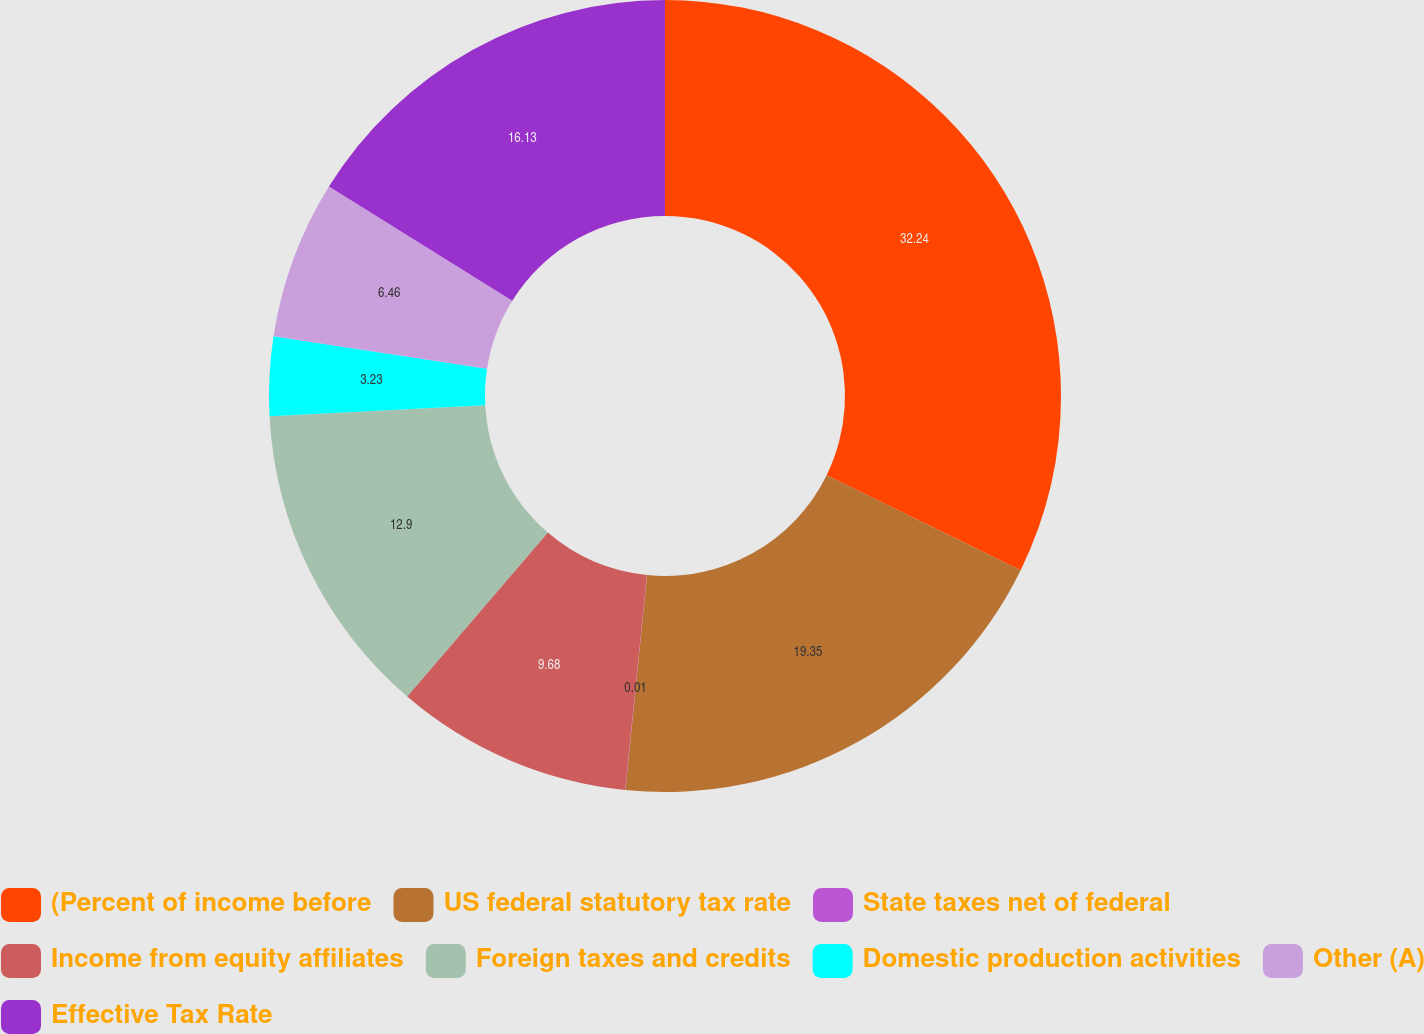Convert chart. <chart><loc_0><loc_0><loc_500><loc_500><pie_chart><fcel>(Percent of income before<fcel>US federal statutory tax rate<fcel>State taxes net of federal<fcel>Income from equity affiliates<fcel>Foreign taxes and credits<fcel>Domestic production activities<fcel>Other (A)<fcel>Effective Tax Rate<nl><fcel>32.25%<fcel>19.35%<fcel>0.01%<fcel>9.68%<fcel>12.9%<fcel>3.23%<fcel>6.46%<fcel>16.13%<nl></chart> 